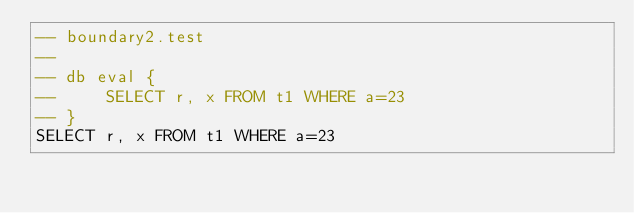<code> <loc_0><loc_0><loc_500><loc_500><_SQL_>-- boundary2.test
-- 
-- db eval {
--     SELECT r, x FROM t1 WHERE a=23
-- }
SELECT r, x FROM t1 WHERE a=23</code> 